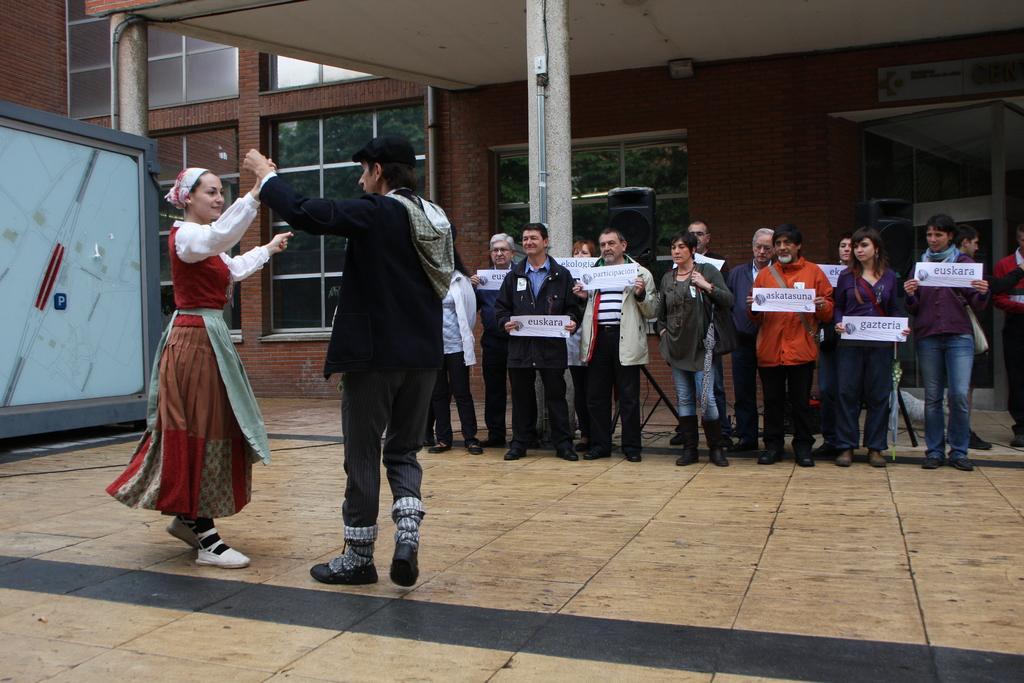Please provide a concise description of this image. In this image there is a couple dancing, beside the couple there are a few other people standing with a smile on their face are holding placards in their hands, behind them there is a building. 